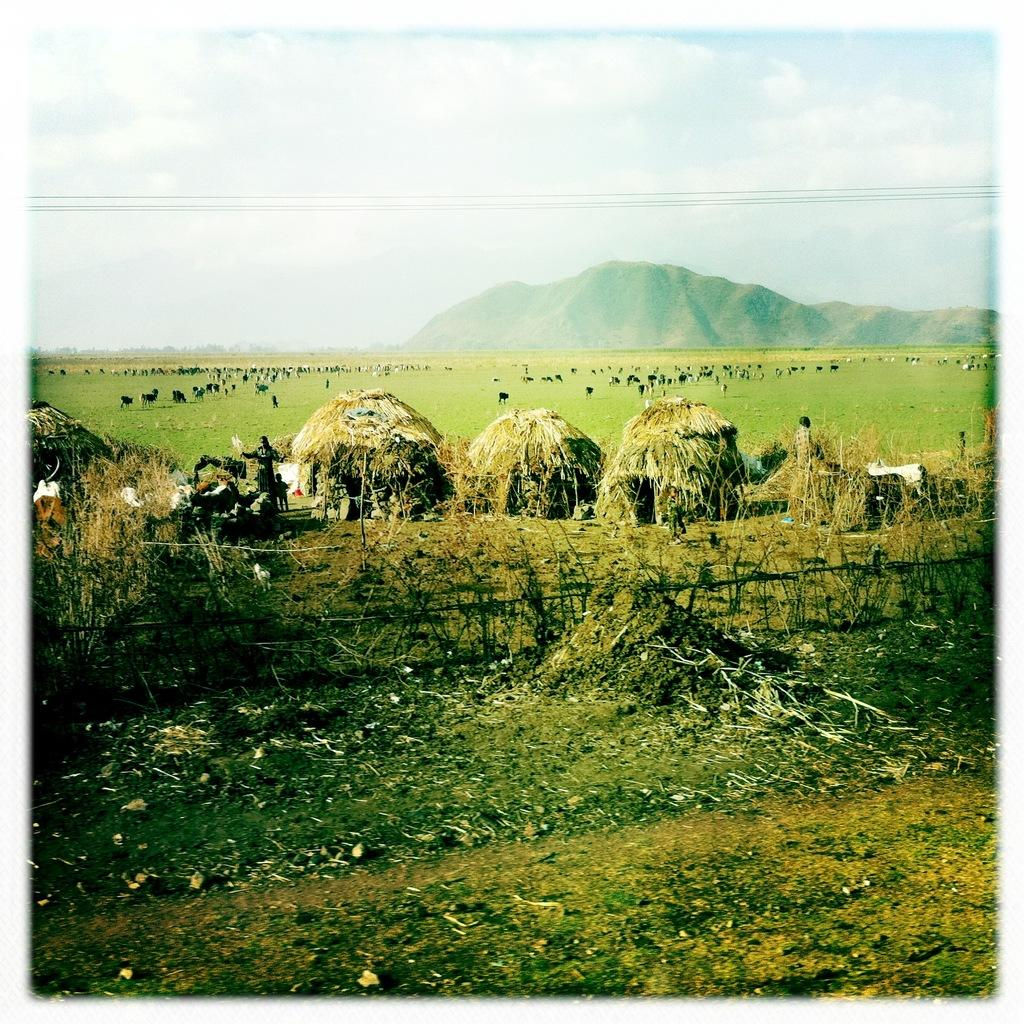What type of vegetation is present in the image? There is grass and plants in the image. Can you describe the people in the image? There are people in the image, but their specific actions or characteristics are not mentioned in the facts. What type of barrier is visible in the image? There is a fence in the image. What type of natural landform can be seen in the image? There are mountains in the image. What type of animals are on the ground in the image? The facts do not specify the type of animals on the ground, only that there are animals present. What is visible in the background of the image? The sky is visible in the background of the image, and it contains clouds. What type of protest is taking place in the image? There is no mention of a protest in the image or the provided facts. What type of advertisement can be seen on the mountains in the image? There is no advertisement present in the image, as the facts only mention the presence of mountains. 